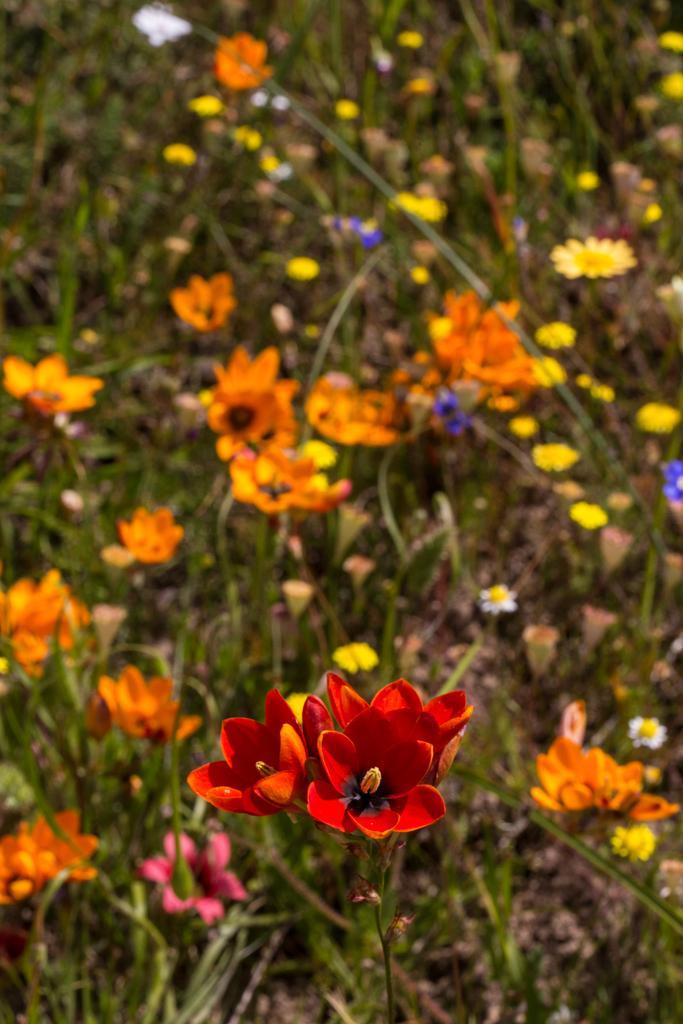Could you give a brief overview of what you see in this image? In this picture I can see number of plants and I see number of flowers which are of red, orange, white, yellow, pink and blue in color. 